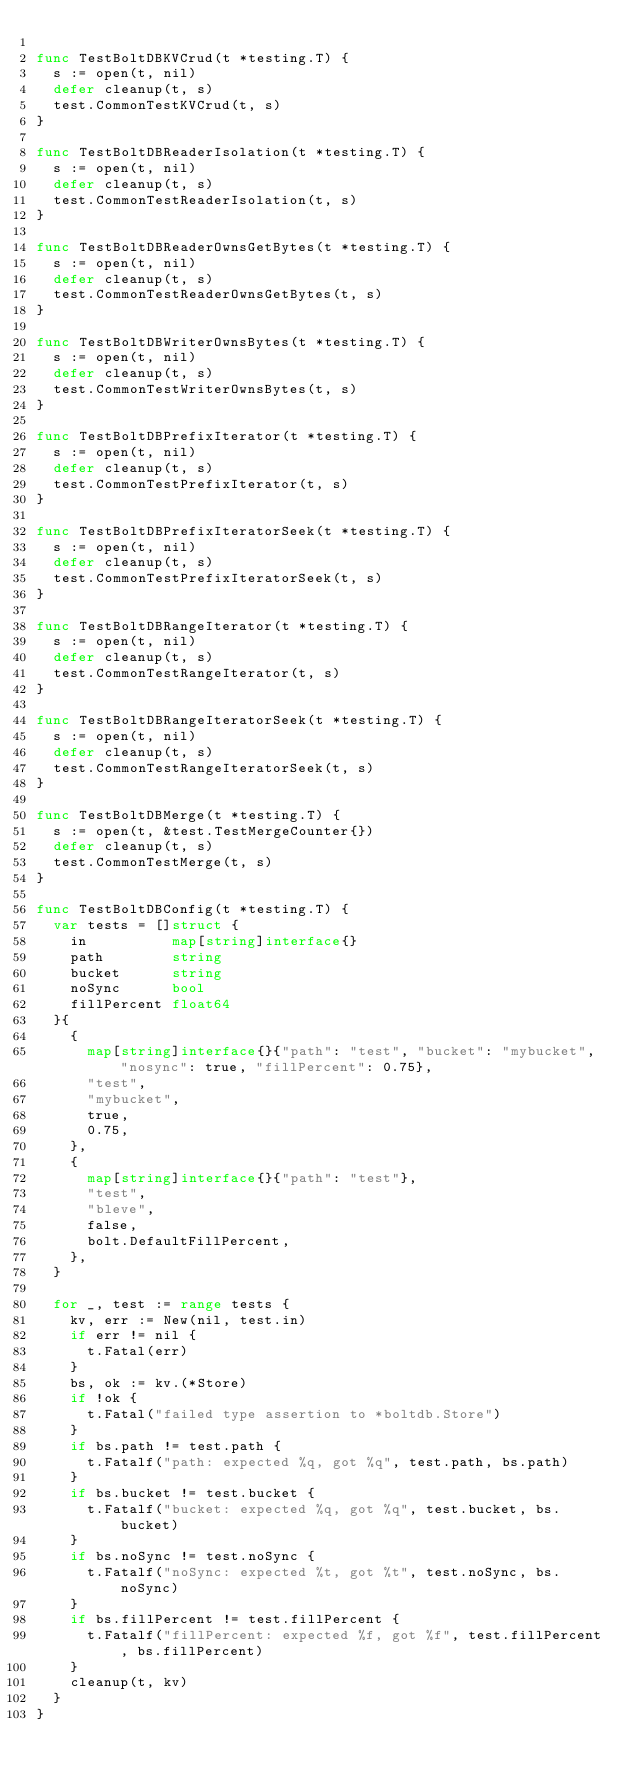<code> <loc_0><loc_0><loc_500><loc_500><_Go_>
func TestBoltDBKVCrud(t *testing.T) {
	s := open(t, nil)
	defer cleanup(t, s)
	test.CommonTestKVCrud(t, s)
}

func TestBoltDBReaderIsolation(t *testing.T) {
	s := open(t, nil)
	defer cleanup(t, s)
	test.CommonTestReaderIsolation(t, s)
}

func TestBoltDBReaderOwnsGetBytes(t *testing.T) {
	s := open(t, nil)
	defer cleanup(t, s)
	test.CommonTestReaderOwnsGetBytes(t, s)
}

func TestBoltDBWriterOwnsBytes(t *testing.T) {
	s := open(t, nil)
	defer cleanup(t, s)
	test.CommonTestWriterOwnsBytes(t, s)
}

func TestBoltDBPrefixIterator(t *testing.T) {
	s := open(t, nil)
	defer cleanup(t, s)
	test.CommonTestPrefixIterator(t, s)
}

func TestBoltDBPrefixIteratorSeek(t *testing.T) {
	s := open(t, nil)
	defer cleanup(t, s)
	test.CommonTestPrefixIteratorSeek(t, s)
}

func TestBoltDBRangeIterator(t *testing.T) {
	s := open(t, nil)
	defer cleanup(t, s)
	test.CommonTestRangeIterator(t, s)
}

func TestBoltDBRangeIteratorSeek(t *testing.T) {
	s := open(t, nil)
	defer cleanup(t, s)
	test.CommonTestRangeIteratorSeek(t, s)
}

func TestBoltDBMerge(t *testing.T) {
	s := open(t, &test.TestMergeCounter{})
	defer cleanup(t, s)
	test.CommonTestMerge(t, s)
}

func TestBoltDBConfig(t *testing.T) {
	var tests = []struct {
		in          map[string]interface{}
		path        string
		bucket      string
		noSync      bool
		fillPercent float64
	}{
		{
			map[string]interface{}{"path": "test", "bucket": "mybucket", "nosync": true, "fillPercent": 0.75},
			"test",
			"mybucket",
			true,
			0.75,
		},
		{
			map[string]interface{}{"path": "test"},
			"test",
			"bleve",
			false,
			bolt.DefaultFillPercent,
		},
	}

	for _, test := range tests {
		kv, err := New(nil, test.in)
		if err != nil {
			t.Fatal(err)
		}
		bs, ok := kv.(*Store)
		if !ok {
			t.Fatal("failed type assertion to *boltdb.Store")
		}
		if bs.path != test.path {
			t.Fatalf("path: expected %q, got %q", test.path, bs.path)
		}
		if bs.bucket != test.bucket {
			t.Fatalf("bucket: expected %q, got %q", test.bucket, bs.bucket)
		}
		if bs.noSync != test.noSync {
			t.Fatalf("noSync: expected %t, got %t", test.noSync, bs.noSync)
		}
		if bs.fillPercent != test.fillPercent {
			t.Fatalf("fillPercent: expected %f, got %f", test.fillPercent, bs.fillPercent)
		}
		cleanup(t, kv)
	}
}
</code> 